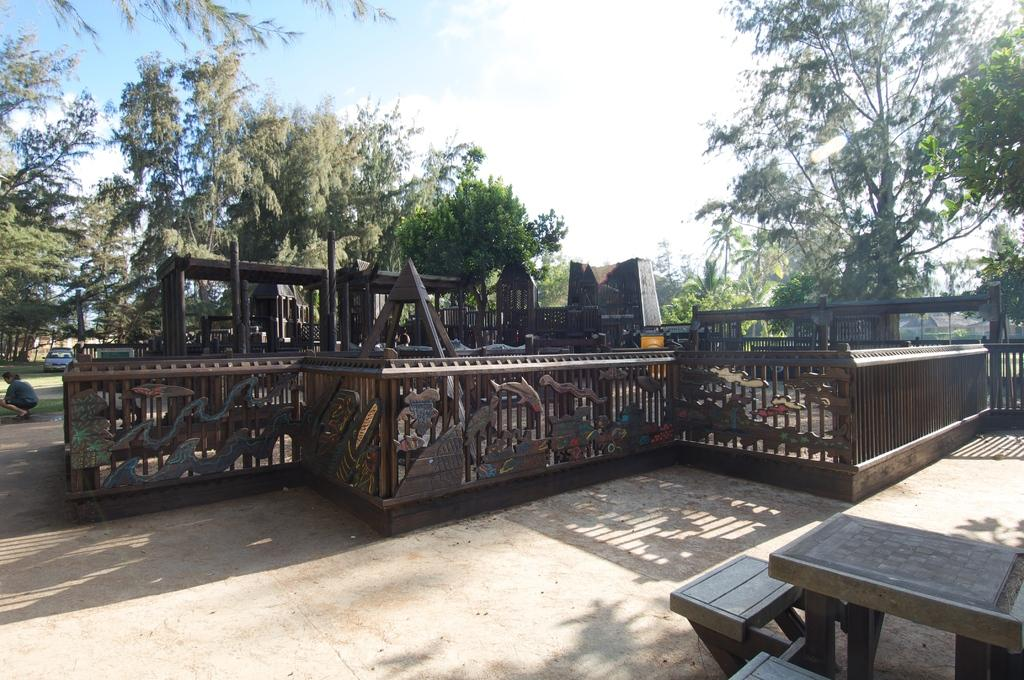What type of material is the railing in the image made of? The railing in the image is made of metal. What can be seen in the background of the image? There are metal objects, trees, a car, and the sky visible in the background of the image. Where are the chairs and table located in the image? The chairs and table are in the bottom right of the image. What type of bread is being used for writing in the image? There is no bread or writing present in the image. What is the income of the person who owns the car in the image? The income of the person who owns the car cannot be determined from the image. 